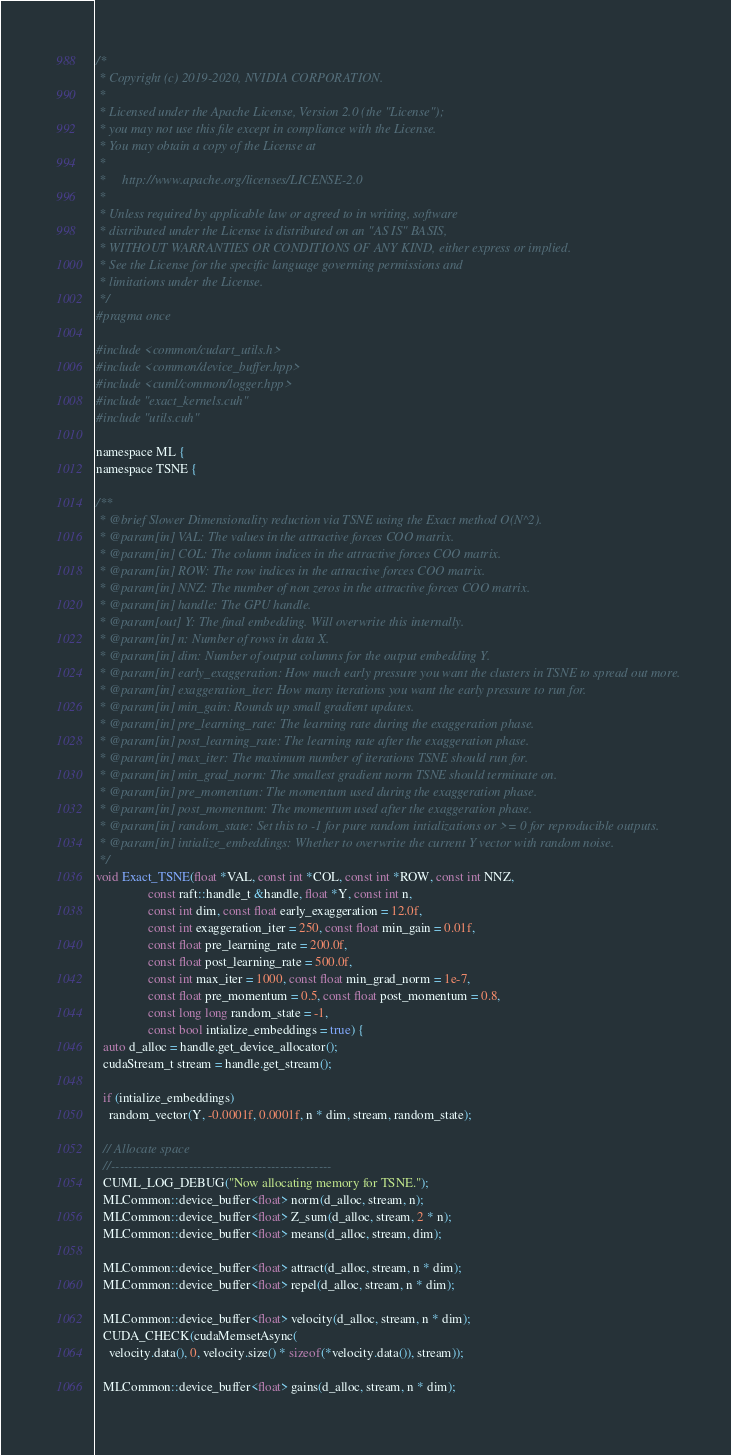Convert code to text. <code><loc_0><loc_0><loc_500><loc_500><_Cuda_>/*
 * Copyright (c) 2019-2020, NVIDIA CORPORATION.
 *
 * Licensed under the Apache License, Version 2.0 (the "License");
 * you may not use this file except in compliance with the License.
 * You may obtain a copy of the License at
 *
 *     http://www.apache.org/licenses/LICENSE-2.0
 *
 * Unless required by applicable law or agreed to in writing, software
 * distributed under the License is distributed on an "AS IS" BASIS,
 * WITHOUT WARRANTIES OR CONDITIONS OF ANY KIND, either express or implied.
 * See the License for the specific language governing permissions and
 * limitations under the License.
 */
#pragma once

#include <common/cudart_utils.h>
#include <common/device_buffer.hpp>
#include <cuml/common/logger.hpp>
#include "exact_kernels.cuh"
#include "utils.cuh"

namespace ML {
namespace TSNE {

/**
 * @brief Slower Dimensionality reduction via TSNE using the Exact method O(N^2).
 * @param[in] VAL: The values in the attractive forces COO matrix.
 * @param[in] COL: The column indices in the attractive forces COO matrix.
 * @param[in] ROW: The row indices in the attractive forces COO matrix.
 * @param[in] NNZ: The number of non zeros in the attractive forces COO matrix.
 * @param[in] handle: The GPU handle.
 * @param[out] Y: The final embedding. Will overwrite this internally.
 * @param[in] n: Number of rows in data X.
 * @param[in] dim: Number of output columns for the output embedding Y.
 * @param[in] early_exaggeration: How much early pressure you want the clusters in TSNE to spread out more.
 * @param[in] exaggeration_iter: How many iterations you want the early pressure to run for.
 * @param[in] min_gain: Rounds up small gradient updates.
 * @param[in] pre_learning_rate: The learning rate during the exaggeration phase.
 * @param[in] post_learning_rate: The learning rate after the exaggeration phase.
 * @param[in] max_iter: The maximum number of iterations TSNE should run for.
 * @param[in] min_grad_norm: The smallest gradient norm TSNE should terminate on.
 * @param[in] pre_momentum: The momentum used during the exaggeration phase.
 * @param[in] post_momentum: The momentum used after the exaggeration phase.
 * @param[in] random_state: Set this to -1 for pure random intializations or >= 0 for reproducible outputs.
 * @param[in] intialize_embeddings: Whether to overwrite the current Y vector with random noise.
 */
void Exact_TSNE(float *VAL, const int *COL, const int *ROW, const int NNZ,
                const raft::handle_t &handle, float *Y, const int n,
                const int dim, const float early_exaggeration = 12.0f,
                const int exaggeration_iter = 250, const float min_gain = 0.01f,
                const float pre_learning_rate = 200.0f,
                const float post_learning_rate = 500.0f,
                const int max_iter = 1000, const float min_grad_norm = 1e-7,
                const float pre_momentum = 0.5, const float post_momentum = 0.8,
                const long long random_state = -1,
                const bool intialize_embeddings = true) {
  auto d_alloc = handle.get_device_allocator();
  cudaStream_t stream = handle.get_stream();

  if (intialize_embeddings)
    random_vector(Y, -0.0001f, 0.0001f, n * dim, stream, random_state);

  // Allocate space
  //---------------------------------------------------
  CUML_LOG_DEBUG("Now allocating memory for TSNE.");
  MLCommon::device_buffer<float> norm(d_alloc, stream, n);
  MLCommon::device_buffer<float> Z_sum(d_alloc, stream, 2 * n);
  MLCommon::device_buffer<float> means(d_alloc, stream, dim);

  MLCommon::device_buffer<float> attract(d_alloc, stream, n * dim);
  MLCommon::device_buffer<float> repel(d_alloc, stream, n * dim);

  MLCommon::device_buffer<float> velocity(d_alloc, stream, n * dim);
  CUDA_CHECK(cudaMemsetAsync(
    velocity.data(), 0, velocity.size() * sizeof(*velocity.data()), stream));

  MLCommon::device_buffer<float> gains(d_alloc, stream, n * dim);</code> 